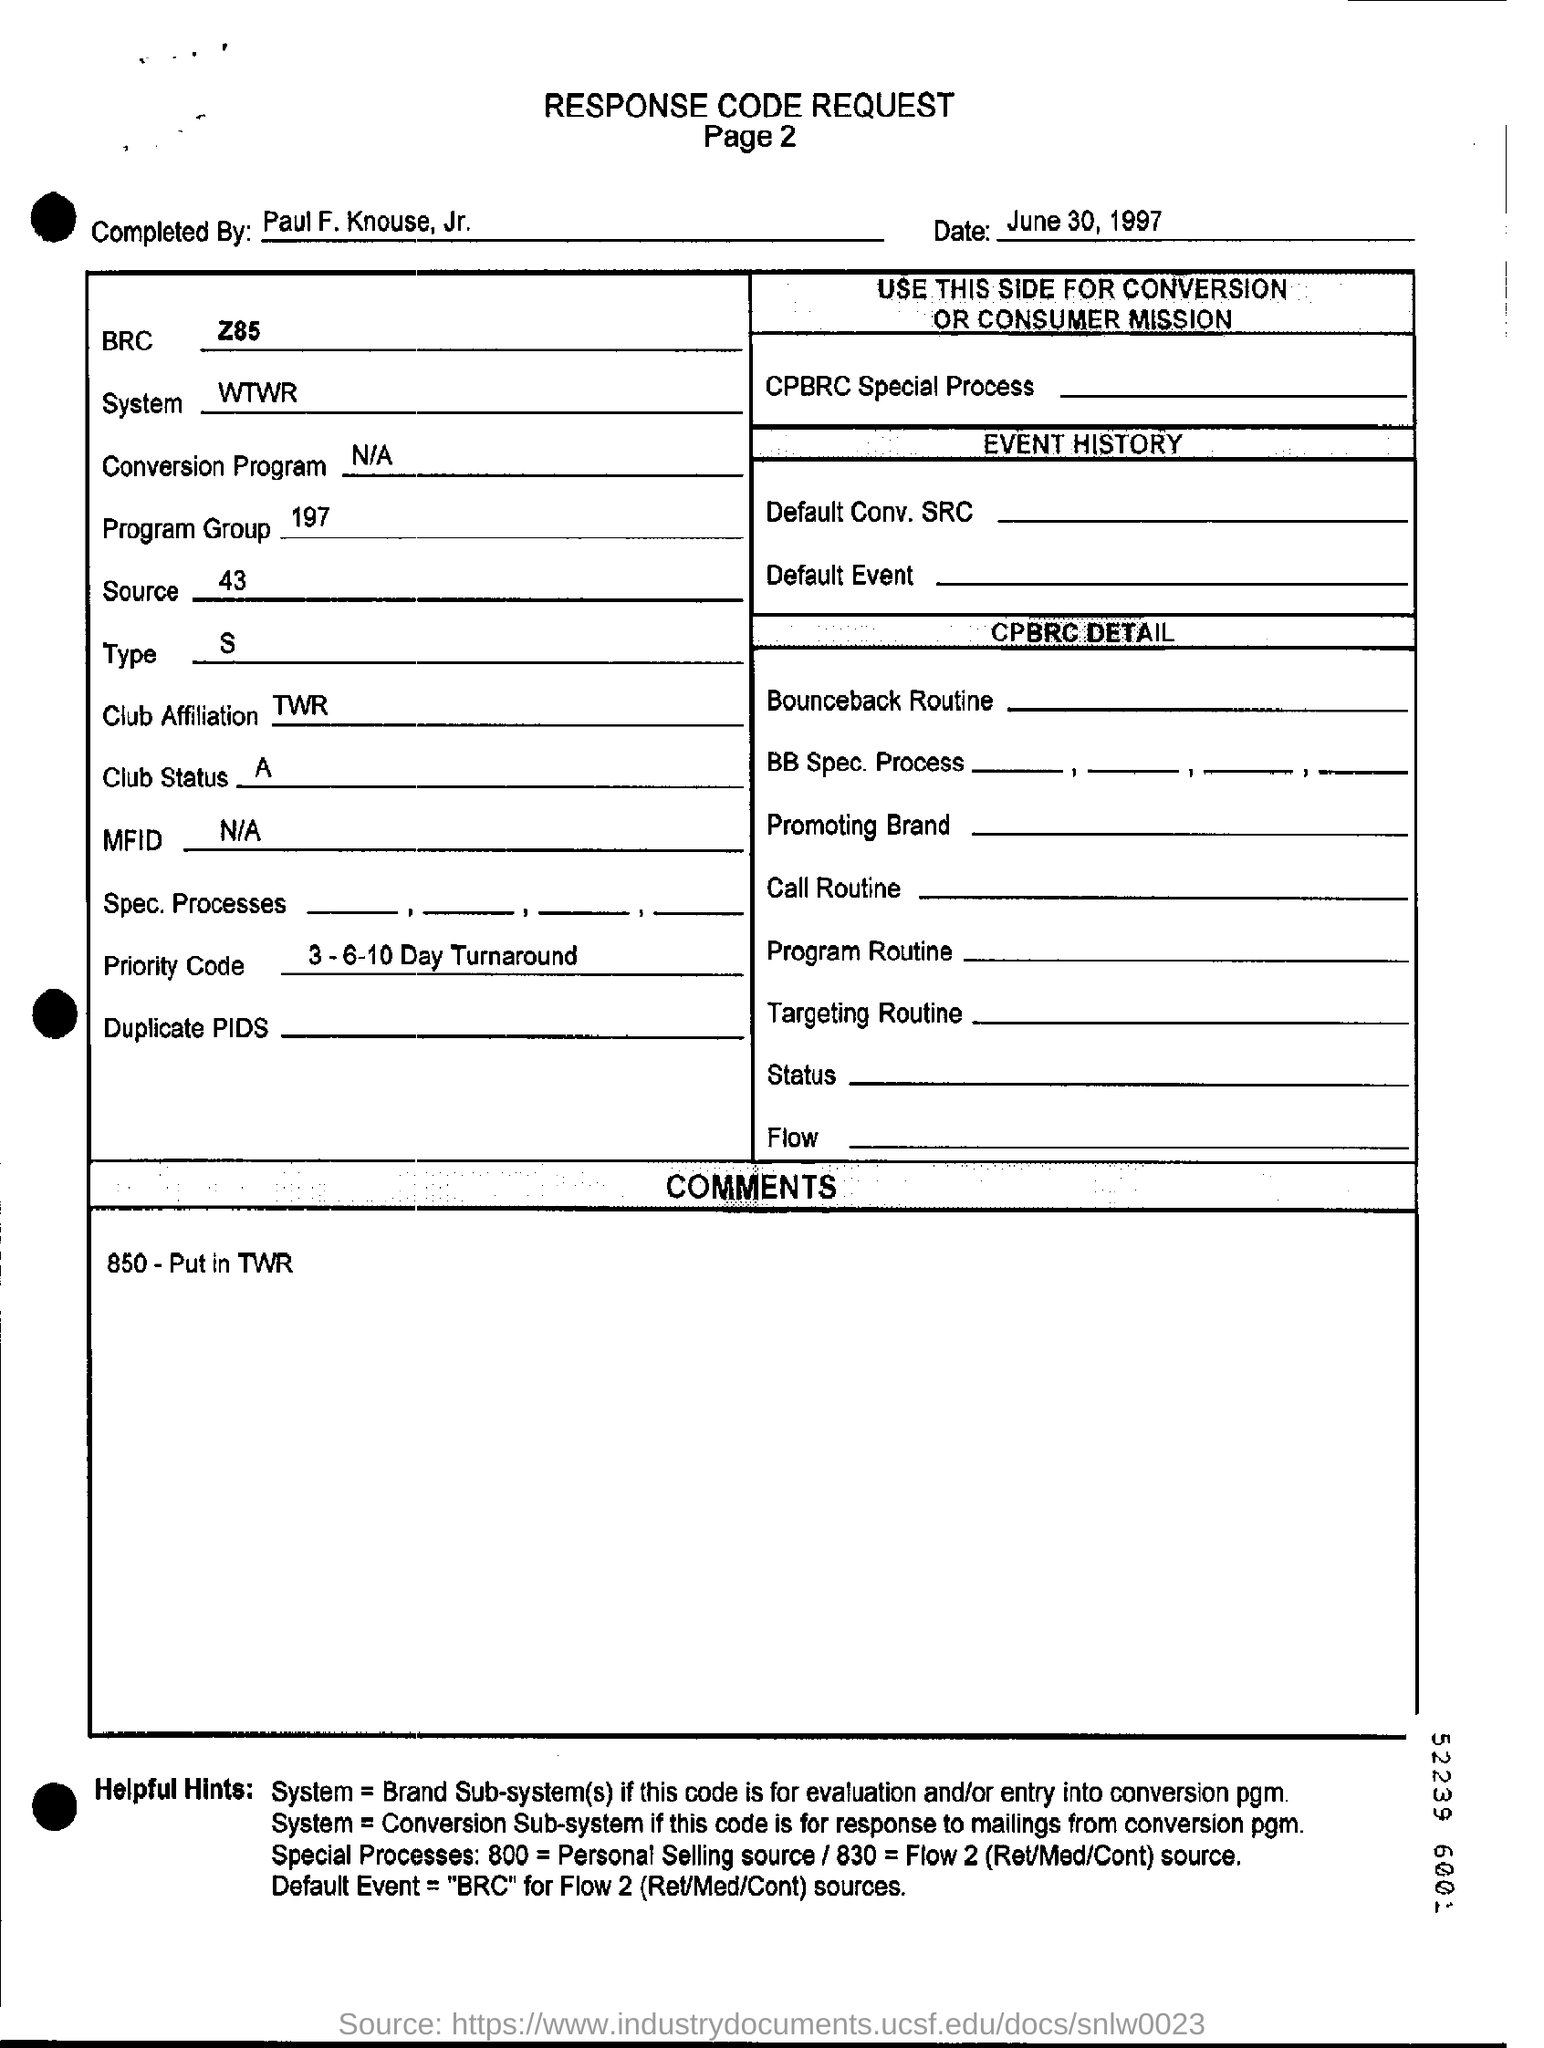Mention a couple of crucial points in this snapshot. The message in the "COMMENTS" box reads, "850-put in TWR." This appears to be a request for information or instruction related to a telecommunications system or protocol. The date of this response code request is June 30, 1997. I, [name], hereby declare that the club status is [insert description of club status]. The completion of the given response code request was performed by Paul F. Knouse, Jr. The system referred to in the document is named WTWR.. 